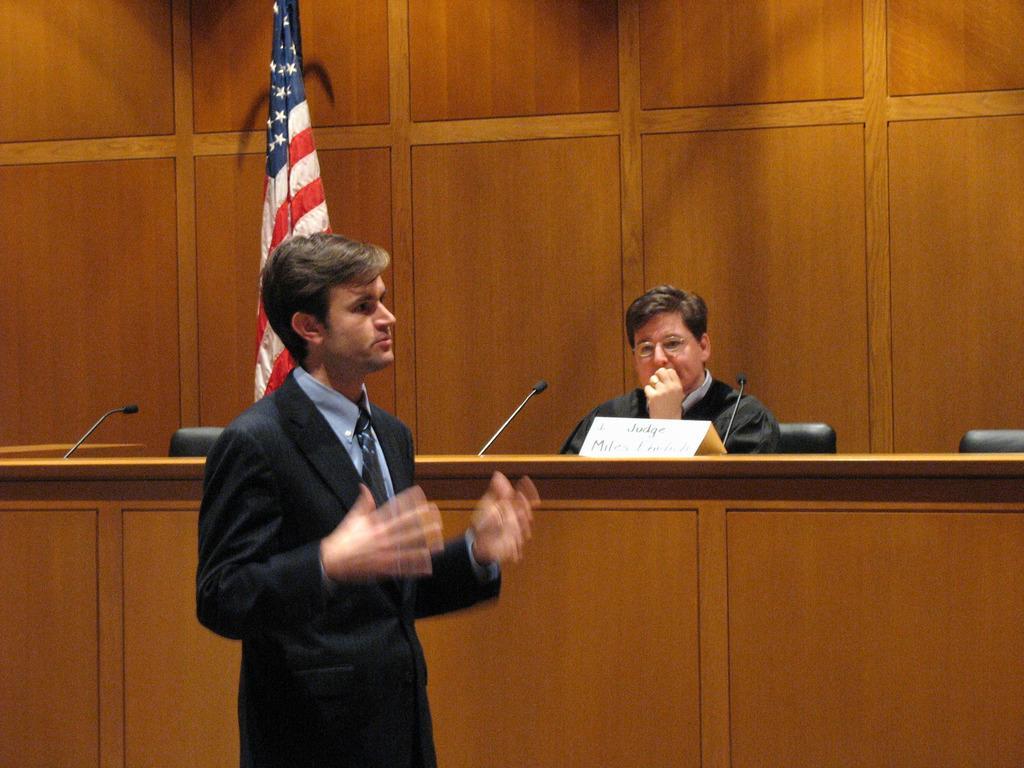Can you describe this image briefly? In this image there is a person standing , and in the background there is a person sitting on the chair , mikes and a name board on the table, chairs, flag. 